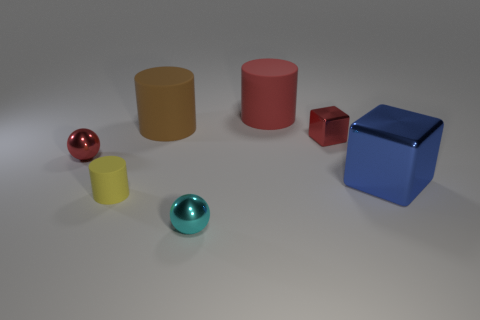What is the color of the large cylinder in front of the big cylinder that is to the right of the brown object?
Ensure brevity in your answer.  Brown. There is a rubber object that is in front of the block that is in front of the tiny red metallic thing on the right side of the small red sphere; what is its shape?
Your response must be concise. Cylinder. What size is the thing that is to the left of the brown matte cylinder and behind the yellow matte cylinder?
Keep it short and to the point. Small. What number of tiny things have the same color as the big metal cube?
Keep it short and to the point. 0. What material is the sphere that is the same color as the small metallic block?
Your answer should be very brief. Metal. What is the brown object made of?
Provide a short and direct response. Rubber. Does the sphere behind the large blue cube have the same material as the tiny cylinder?
Make the answer very short. No. What is the shape of the metal thing that is in front of the blue shiny block?
Provide a short and direct response. Sphere. There is a yellow cylinder that is the same size as the cyan metal object; what is its material?
Give a very brief answer. Rubber. What number of things are small things behind the cyan sphere or objects that are in front of the large blue cube?
Give a very brief answer. 4. 